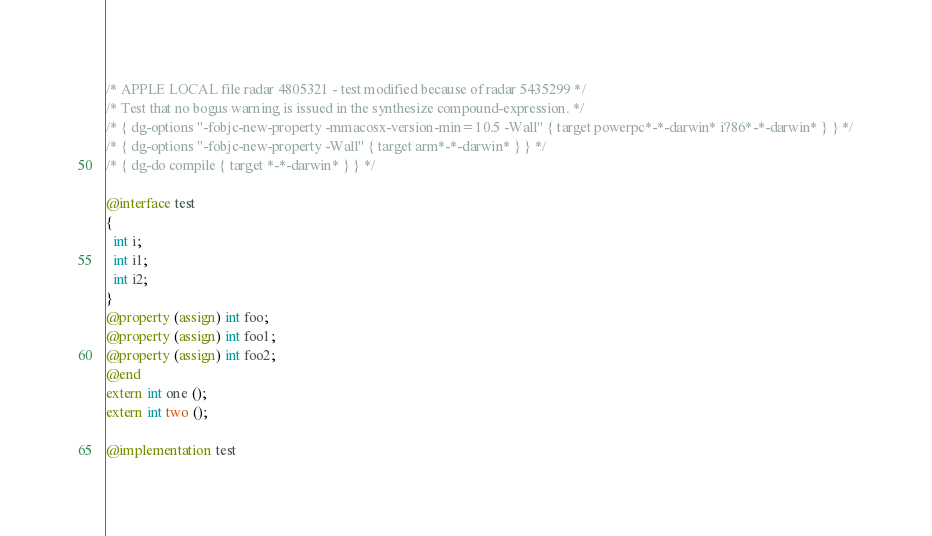<code> <loc_0><loc_0><loc_500><loc_500><_ObjectiveC_>/* APPLE LOCAL file radar 4805321 - test modified because of radar 5435299 */
/* Test that no bogus warning is issued in the synthesize compound-expression. */
/* { dg-options "-fobjc-new-property -mmacosx-version-min=10.5 -Wall" { target powerpc*-*-darwin* i?86*-*-darwin* } } */
/* { dg-options "-fobjc-new-property -Wall" { target arm*-*-darwin* } } */
/* { dg-do compile { target *-*-darwin* } } */

@interface test
{
  int i;
  int i1;
  int i2;
}
@property (assign) int foo;
@property (assign) int foo1;
@property (assign) int foo2;
@end
extern int one ();
extern int two ();

@implementation test</code> 